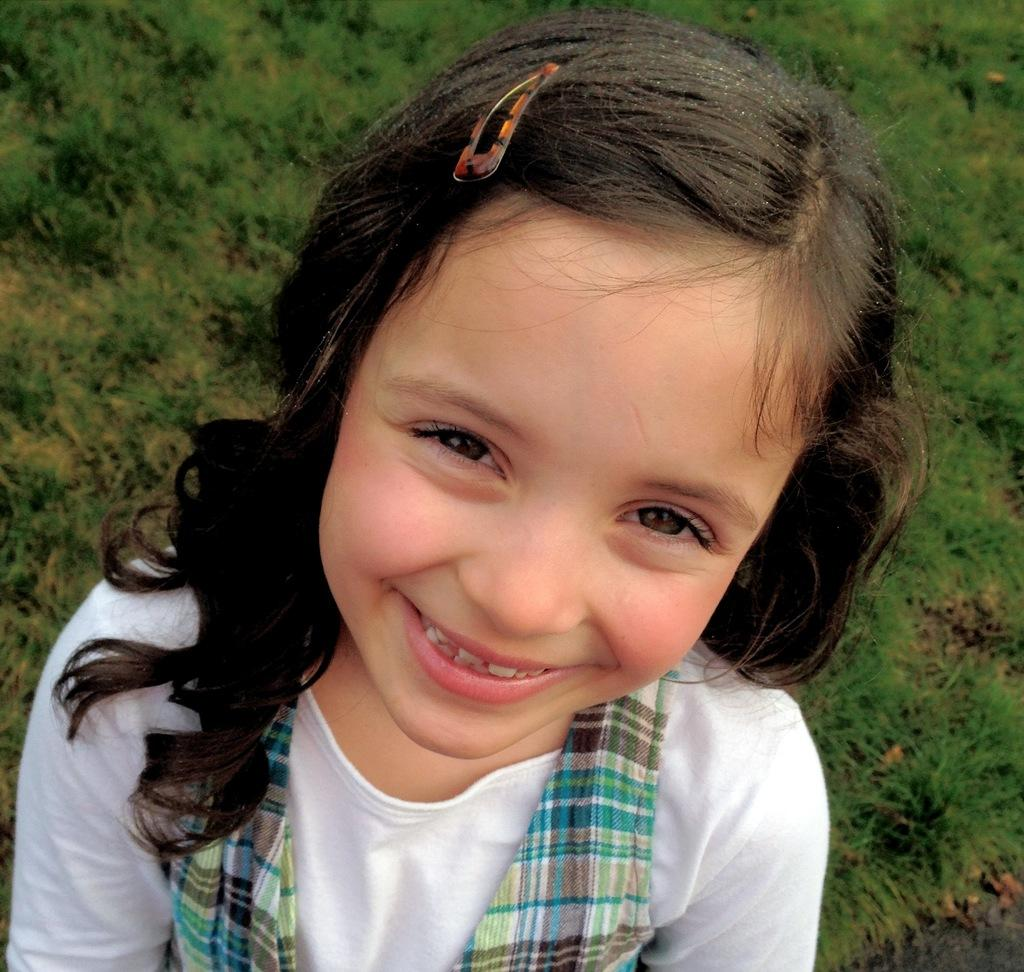Who is the main subject in the image? There is a girl in the image. What is the girl doing in the image? The girl is smiling in the image. What can be seen in the background of the image? There is grass visible in the background of the image. What type of trouble is the girl causing with her partner in the image? There is no indication of trouble or a partner in the image; the girl is simply smiling. 